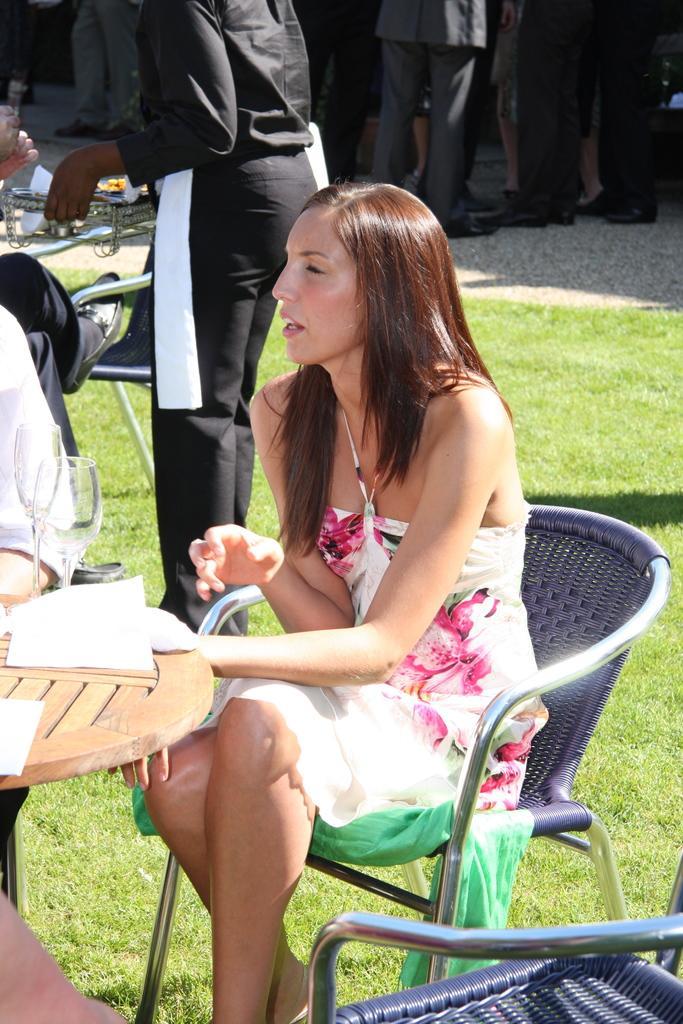Please provide a concise description of this image. In the image on the ground there is a lot of grass and the woman is sitting on chair. She is wearing a floral frock behind her there is a man who is wearing a black outfit and he is holding a tray. Beside the man there are lot of people standing and they are all wearing formal suits. 